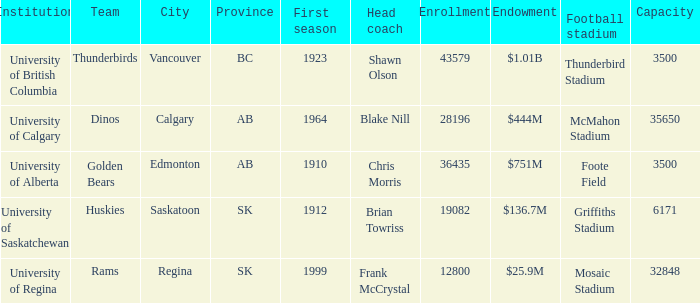Could you parse the entire table as a dict? {'header': ['Institution', 'Team', 'City', 'Province', 'First season', 'Head coach', 'Enrollment', 'Endowment', 'Football stadium', 'Capacity'], 'rows': [['University of British Columbia', 'Thunderbirds', 'Vancouver', 'BC', '1923', 'Shawn Olson', '43579', '$1.01B', 'Thunderbird Stadium', '3500'], ['University of Calgary', 'Dinos', 'Calgary', 'AB', '1964', 'Blake Nill', '28196', '$444M', 'McMahon Stadium', '35650'], ['University of Alberta', 'Golden Bears', 'Edmonton', 'AB', '1910', 'Chris Morris', '36435', '$751M', 'Foote Field', '3500'], ['University of Saskatchewan', 'Huskies', 'Saskatoon', 'SK', '1912', 'Brian Towriss', '19082', '$136.7M', 'Griffiths Stadium', '6171'], ['University of Regina', 'Rams', 'Regina', 'SK', '1999', 'Frank McCrystal', '12800', '$25.9M', 'Mosaic Stadium', '32848']]} What year did University of Saskatchewan have their first season? 1912.0. 